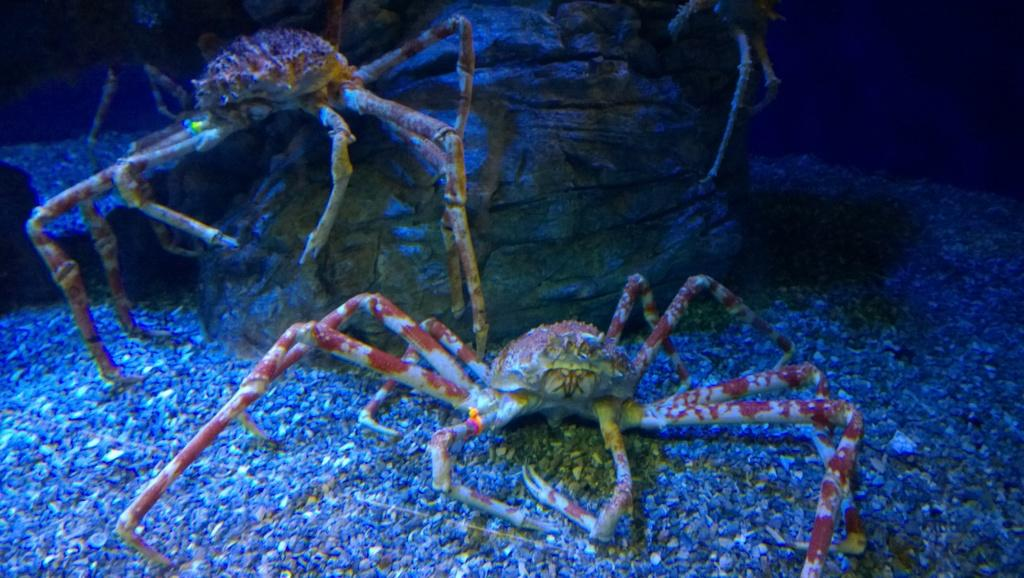What type of animals can be seen in the image? There are crabs in the image. What can be seen on the ground in the image? There are stones on the ground in the image. What type of coil is being used in the image? There is no coil present in the image. What type of operation is being performed on the crabs in the image? There is no operation being performed on the crabs in the image. What type of crate is visible in the image? There is no crate present in the image. 